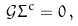<formula> <loc_0><loc_0><loc_500><loc_500>\mathcal { G } \Sigma ^ { c } = 0 \, ,</formula> 